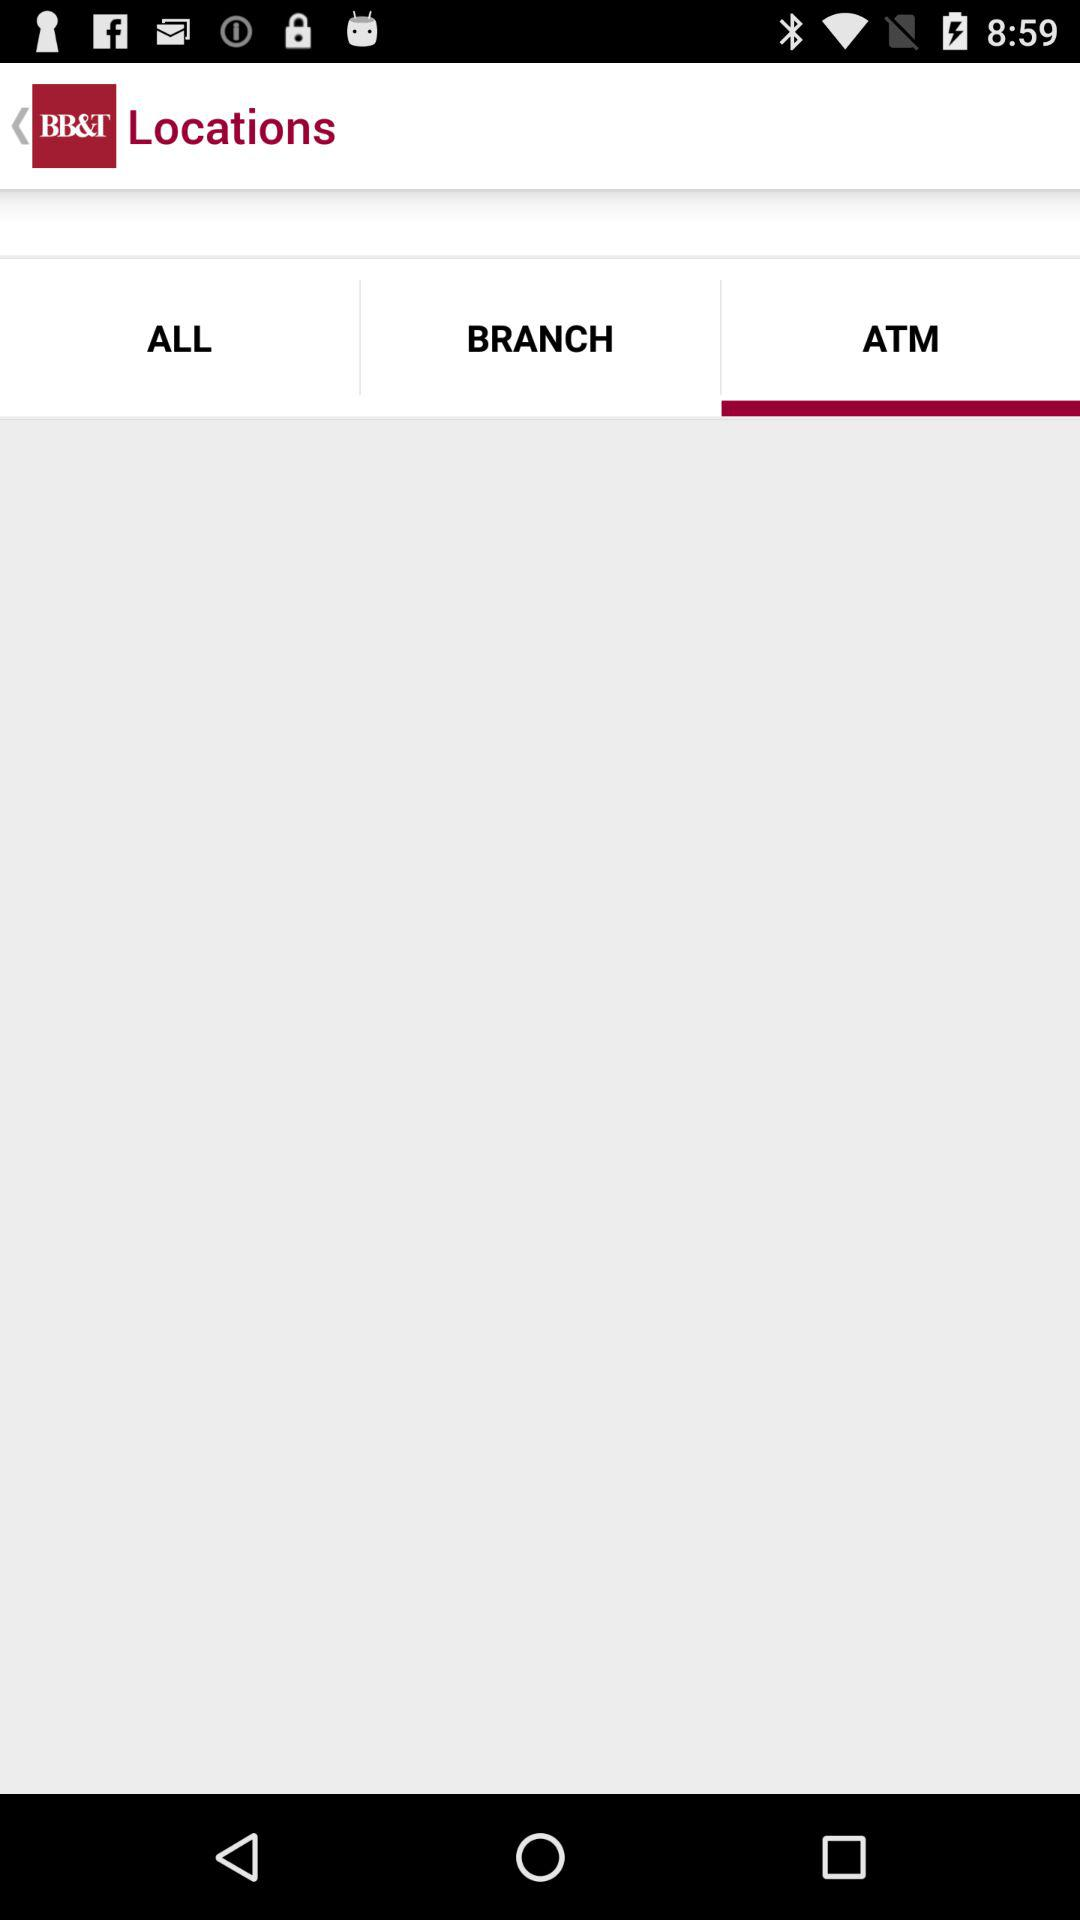Which tab is selected? The selected tab is "ATM". 